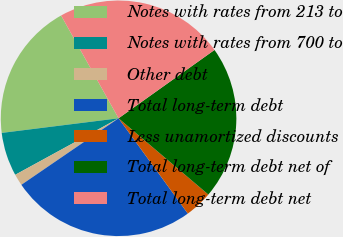<chart> <loc_0><loc_0><loc_500><loc_500><pie_chart><fcel>Notes with rates from 213 to<fcel>Notes with rates from 700 to<fcel>Other debt<fcel>Total long-term debt<fcel>Less unamortized discounts<fcel>Total long-term debt net of<fcel>Total long-term debt net<nl><fcel>18.87%<fcel>5.98%<fcel>1.59%<fcel>25.45%<fcel>3.79%<fcel>21.06%<fcel>23.26%<nl></chart> 